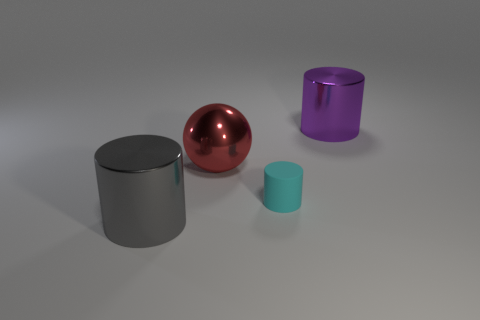Does the big shiny cylinder that is in front of the big purple thing have the same color as the metal cylinder that is behind the ball?
Your answer should be compact. No. What is the thing that is right of the metal ball and behind the small cyan cylinder made of?
Provide a succinct answer. Metal. Are any small brown matte cylinders visible?
Make the answer very short. No. What shape is the large red thing that is the same material as the gray cylinder?
Provide a short and direct response. Sphere. There is a gray metallic thing; does it have the same shape as the shiny object to the right of the cyan rubber object?
Offer a terse response. Yes. There is a big cylinder behind the large metal cylinder left of the big red thing; what is its material?
Give a very brief answer. Metal. What number of other things are the same shape as the red shiny object?
Your response must be concise. 0. Is the shape of the big shiny thing that is in front of the small rubber cylinder the same as the shiny thing that is behind the red thing?
Offer a terse response. Yes. Is there anything else that has the same material as the red ball?
Your response must be concise. Yes. What is the material of the purple cylinder?
Ensure brevity in your answer.  Metal. 